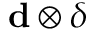Convert formula to latex. <formula><loc_0><loc_0><loc_500><loc_500>{ d } \otimes \delta</formula> 